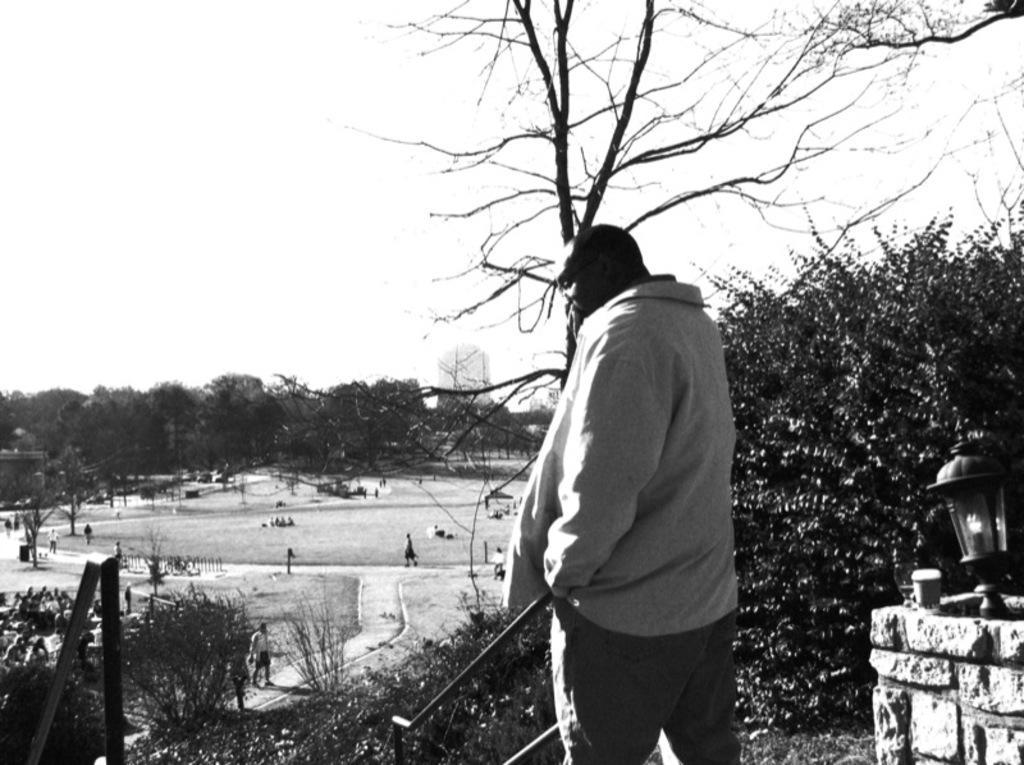Please provide a concise description of this image. In this picture there is a person standing and there are iron rods on either sides of him and there is a lamp in the right corner and there are few people and trees in the background. 